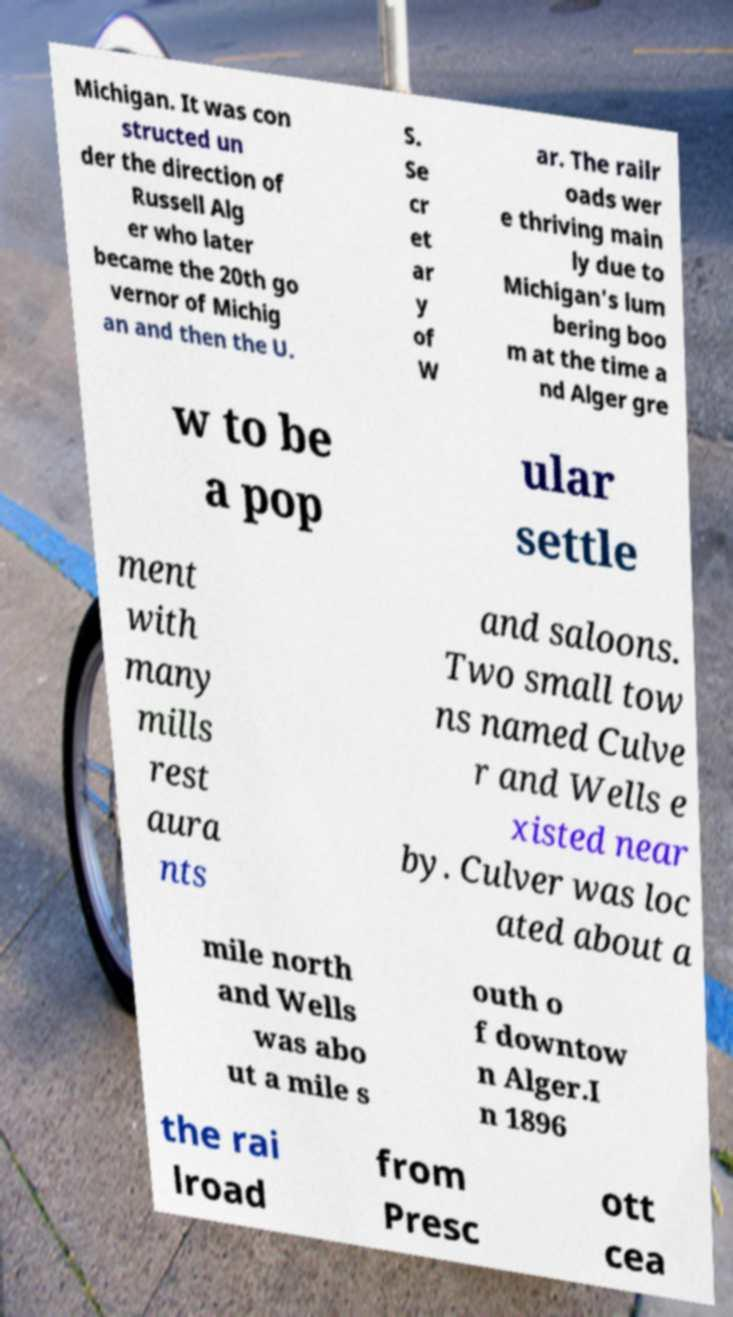Please identify and transcribe the text found in this image. Michigan. It was con structed un der the direction of Russell Alg er who later became the 20th go vernor of Michig an and then the U. S. Se cr et ar y of W ar. The railr oads wer e thriving main ly due to Michigan's lum bering boo m at the time a nd Alger gre w to be a pop ular settle ment with many mills rest aura nts and saloons. Two small tow ns named Culve r and Wells e xisted near by. Culver was loc ated about a mile north and Wells was abo ut a mile s outh o f downtow n Alger.I n 1896 the rai lroad from Presc ott cea 